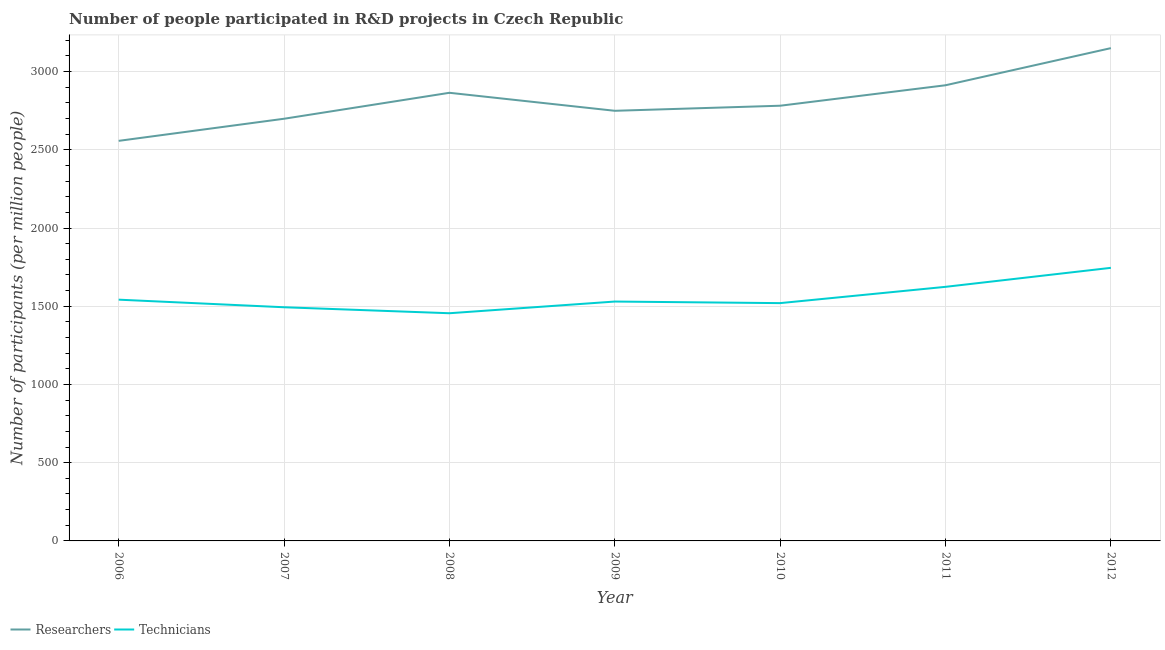Does the line corresponding to number of technicians intersect with the line corresponding to number of researchers?
Your answer should be very brief. No. Is the number of lines equal to the number of legend labels?
Keep it short and to the point. Yes. What is the number of researchers in 2010?
Keep it short and to the point. 2781.85. Across all years, what is the maximum number of researchers?
Keep it short and to the point. 3149.99. Across all years, what is the minimum number of researchers?
Offer a very short reply. 2557.31. In which year was the number of technicians maximum?
Provide a short and direct response. 2012. In which year was the number of technicians minimum?
Your answer should be very brief. 2008. What is the total number of technicians in the graph?
Your answer should be compact. 1.09e+04. What is the difference between the number of researchers in 2008 and that in 2012?
Offer a very short reply. -285.47. What is the difference between the number of researchers in 2006 and the number of technicians in 2008?
Offer a very short reply. 1101.93. What is the average number of researchers per year?
Give a very brief answer. 2816.34. In the year 2011, what is the difference between the number of technicians and number of researchers?
Provide a succinct answer. -1288.49. What is the ratio of the number of researchers in 2009 to that in 2010?
Give a very brief answer. 0.99. What is the difference between the highest and the second highest number of technicians?
Your answer should be very brief. 121.45. What is the difference between the highest and the lowest number of technicians?
Offer a terse response. 290.21. Is the sum of the number of researchers in 2009 and 2012 greater than the maximum number of technicians across all years?
Your answer should be very brief. Yes. How many lines are there?
Give a very brief answer. 2. How many years are there in the graph?
Provide a succinct answer. 7. What is the difference between two consecutive major ticks on the Y-axis?
Give a very brief answer. 500. Does the graph contain any zero values?
Provide a succinct answer. No. Does the graph contain grids?
Your response must be concise. Yes. Where does the legend appear in the graph?
Offer a terse response. Bottom left. What is the title of the graph?
Provide a short and direct response. Number of people participated in R&D projects in Czech Republic. Does "Exports" appear as one of the legend labels in the graph?
Offer a very short reply. No. What is the label or title of the Y-axis?
Your answer should be compact. Number of participants (per million people). What is the Number of participants (per million people) of Researchers in 2006?
Your answer should be compact. 2557.31. What is the Number of participants (per million people) in Technicians in 2006?
Provide a succinct answer. 1542.15. What is the Number of participants (per million people) of Researchers in 2007?
Ensure brevity in your answer.  2698.6. What is the Number of participants (per million people) in Technicians in 2007?
Keep it short and to the point. 1493.68. What is the Number of participants (per million people) of Researchers in 2008?
Ensure brevity in your answer.  2864.52. What is the Number of participants (per million people) in Technicians in 2008?
Offer a very short reply. 1455.38. What is the Number of participants (per million people) in Researchers in 2009?
Provide a short and direct response. 2749.45. What is the Number of participants (per million people) of Technicians in 2009?
Your response must be concise. 1530.09. What is the Number of participants (per million people) in Researchers in 2010?
Offer a terse response. 2781.85. What is the Number of participants (per million people) of Technicians in 2010?
Provide a succinct answer. 1520.06. What is the Number of participants (per million people) of Researchers in 2011?
Your answer should be compact. 2912.63. What is the Number of participants (per million people) of Technicians in 2011?
Your answer should be compact. 1624.14. What is the Number of participants (per million people) in Researchers in 2012?
Offer a very short reply. 3149.99. What is the Number of participants (per million people) in Technicians in 2012?
Give a very brief answer. 1745.59. Across all years, what is the maximum Number of participants (per million people) in Researchers?
Your answer should be compact. 3149.99. Across all years, what is the maximum Number of participants (per million people) of Technicians?
Make the answer very short. 1745.59. Across all years, what is the minimum Number of participants (per million people) in Researchers?
Provide a succinct answer. 2557.31. Across all years, what is the minimum Number of participants (per million people) of Technicians?
Your answer should be very brief. 1455.38. What is the total Number of participants (per million people) of Researchers in the graph?
Ensure brevity in your answer.  1.97e+04. What is the total Number of participants (per million people) in Technicians in the graph?
Your answer should be compact. 1.09e+04. What is the difference between the Number of participants (per million people) of Researchers in 2006 and that in 2007?
Keep it short and to the point. -141.29. What is the difference between the Number of participants (per million people) in Technicians in 2006 and that in 2007?
Give a very brief answer. 48.47. What is the difference between the Number of participants (per million people) in Researchers in 2006 and that in 2008?
Offer a very short reply. -307.21. What is the difference between the Number of participants (per million people) of Technicians in 2006 and that in 2008?
Provide a succinct answer. 86.78. What is the difference between the Number of participants (per million people) in Researchers in 2006 and that in 2009?
Ensure brevity in your answer.  -192.14. What is the difference between the Number of participants (per million people) in Technicians in 2006 and that in 2009?
Make the answer very short. 12.06. What is the difference between the Number of participants (per million people) of Researchers in 2006 and that in 2010?
Provide a short and direct response. -224.55. What is the difference between the Number of participants (per million people) of Technicians in 2006 and that in 2010?
Your response must be concise. 22.1. What is the difference between the Number of participants (per million people) in Researchers in 2006 and that in 2011?
Your answer should be compact. -355.32. What is the difference between the Number of participants (per million people) in Technicians in 2006 and that in 2011?
Offer a very short reply. -81.98. What is the difference between the Number of participants (per million people) of Researchers in 2006 and that in 2012?
Your response must be concise. -592.69. What is the difference between the Number of participants (per million people) of Technicians in 2006 and that in 2012?
Provide a short and direct response. -203.43. What is the difference between the Number of participants (per million people) of Researchers in 2007 and that in 2008?
Give a very brief answer. -165.92. What is the difference between the Number of participants (per million people) of Technicians in 2007 and that in 2008?
Make the answer very short. 38.3. What is the difference between the Number of participants (per million people) in Researchers in 2007 and that in 2009?
Offer a terse response. -50.85. What is the difference between the Number of participants (per million people) of Technicians in 2007 and that in 2009?
Offer a very short reply. -36.41. What is the difference between the Number of participants (per million people) in Researchers in 2007 and that in 2010?
Keep it short and to the point. -83.26. What is the difference between the Number of participants (per million people) in Technicians in 2007 and that in 2010?
Provide a succinct answer. -26.38. What is the difference between the Number of participants (per million people) of Researchers in 2007 and that in 2011?
Make the answer very short. -214.03. What is the difference between the Number of participants (per million people) of Technicians in 2007 and that in 2011?
Provide a short and direct response. -130.45. What is the difference between the Number of participants (per million people) in Researchers in 2007 and that in 2012?
Provide a short and direct response. -451.39. What is the difference between the Number of participants (per million people) of Technicians in 2007 and that in 2012?
Make the answer very short. -251.9. What is the difference between the Number of participants (per million people) of Researchers in 2008 and that in 2009?
Provide a short and direct response. 115.07. What is the difference between the Number of participants (per million people) of Technicians in 2008 and that in 2009?
Your answer should be compact. -74.72. What is the difference between the Number of participants (per million people) of Researchers in 2008 and that in 2010?
Offer a terse response. 82.66. What is the difference between the Number of participants (per million people) of Technicians in 2008 and that in 2010?
Your answer should be very brief. -64.68. What is the difference between the Number of participants (per million people) of Researchers in 2008 and that in 2011?
Give a very brief answer. -48.11. What is the difference between the Number of participants (per million people) in Technicians in 2008 and that in 2011?
Give a very brief answer. -168.76. What is the difference between the Number of participants (per million people) in Researchers in 2008 and that in 2012?
Your answer should be very brief. -285.47. What is the difference between the Number of participants (per million people) of Technicians in 2008 and that in 2012?
Provide a succinct answer. -290.21. What is the difference between the Number of participants (per million people) in Researchers in 2009 and that in 2010?
Provide a short and direct response. -32.4. What is the difference between the Number of participants (per million people) of Technicians in 2009 and that in 2010?
Ensure brevity in your answer.  10.04. What is the difference between the Number of participants (per million people) of Researchers in 2009 and that in 2011?
Provide a short and direct response. -163.18. What is the difference between the Number of participants (per million people) in Technicians in 2009 and that in 2011?
Give a very brief answer. -94.04. What is the difference between the Number of participants (per million people) in Researchers in 2009 and that in 2012?
Give a very brief answer. -400.54. What is the difference between the Number of participants (per million people) in Technicians in 2009 and that in 2012?
Make the answer very short. -215.49. What is the difference between the Number of participants (per million people) of Researchers in 2010 and that in 2011?
Offer a very short reply. -130.77. What is the difference between the Number of participants (per million people) in Technicians in 2010 and that in 2011?
Offer a terse response. -104.08. What is the difference between the Number of participants (per million people) of Researchers in 2010 and that in 2012?
Your answer should be very brief. -368.14. What is the difference between the Number of participants (per million people) of Technicians in 2010 and that in 2012?
Your response must be concise. -225.53. What is the difference between the Number of participants (per million people) in Researchers in 2011 and that in 2012?
Your response must be concise. -237.36. What is the difference between the Number of participants (per million people) of Technicians in 2011 and that in 2012?
Keep it short and to the point. -121.45. What is the difference between the Number of participants (per million people) in Researchers in 2006 and the Number of participants (per million people) in Technicians in 2007?
Provide a succinct answer. 1063.62. What is the difference between the Number of participants (per million people) in Researchers in 2006 and the Number of participants (per million people) in Technicians in 2008?
Ensure brevity in your answer.  1101.93. What is the difference between the Number of participants (per million people) of Researchers in 2006 and the Number of participants (per million people) of Technicians in 2009?
Provide a succinct answer. 1027.21. What is the difference between the Number of participants (per million people) of Researchers in 2006 and the Number of participants (per million people) of Technicians in 2010?
Offer a terse response. 1037.25. What is the difference between the Number of participants (per million people) in Researchers in 2006 and the Number of participants (per million people) in Technicians in 2011?
Give a very brief answer. 933.17. What is the difference between the Number of participants (per million people) of Researchers in 2006 and the Number of participants (per million people) of Technicians in 2012?
Offer a very short reply. 811.72. What is the difference between the Number of participants (per million people) of Researchers in 2007 and the Number of participants (per million people) of Technicians in 2008?
Give a very brief answer. 1243.22. What is the difference between the Number of participants (per million people) in Researchers in 2007 and the Number of participants (per million people) in Technicians in 2009?
Provide a succinct answer. 1168.5. What is the difference between the Number of participants (per million people) of Researchers in 2007 and the Number of participants (per million people) of Technicians in 2010?
Offer a very short reply. 1178.54. What is the difference between the Number of participants (per million people) in Researchers in 2007 and the Number of participants (per million people) in Technicians in 2011?
Your answer should be compact. 1074.46. What is the difference between the Number of participants (per million people) in Researchers in 2007 and the Number of participants (per million people) in Technicians in 2012?
Ensure brevity in your answer.  953.01. What is the difference between the Number of participants (per million people) in Researchers in 2008 and the Number of participants (per million people) in Technicians in 2009?
Your answer should be very brief. 1334.42. What is the difference between the Number of participants (per million people) of Researchers in 2008 and the Number of participants (per million people) of Technicians in 2010?
Your answer should be very brief. 1344.46. What is the difference between the Number of participants (per million people) of Researchers in 2008 and the Number of participants (per million people) of Technicians in 2011?
Provide a succinct answer. 1240.38. What is the difference between the Number of participants (per million people) in Researchers in 2008 and the Number of participants (per million people) in Technicians in 2012?
Your response must be concise. 1118.93. What is the difference between the Number of participants (per million people) of Researchers in 2009 and the Number of participants (per million people) of Technicians in 2010?
Ensure brevity in your answer.  1229.39. What is the difference between the Number of participants (per million people) of Researchers in 2009 and the Number of participants (per million people) of Technicians in 2011?
Your response must be concise. 1125.31. What is the difference between the Number of participants (per million people) in Researchers in 2009 and the Number of participants (per million people) in Technicians in 2012?
Ensure brevity in your answer.  1003.86. What is the difference between the Number of participants (per million people) of Researchers in 2010 and the Number of participants (per million people) of Technicians in 2011?
Keep it short and to the point. 1157.72. What is the difference between the Number of participants (per million people) of Researchers in 2010 and the Number of participants (per million people) of Technicians in 2012?
Ensure brevity in your answer.  1036.27. What is the difference between the Number of participants (per million people) in Researchers in 2011 and the Number of participants (per million people) in Technicians in 2012?
Provide a short and direct response. 1167.04. What is the average Number of participants (per million people) of Researchers per year?
Provide a succinct answer. 2816.34. What is the average Number of participants (per million people) of Technicians per year?
Make the answer very short. 1558.73. In the year 2006, what is the difference between the Number of participants (per million people) of Researchers and Number of participants (per million people) of Technicians?
Ensure brevity in your answer.  1015.15. In the year 2007, what is the difference between the Number of participants (per million people) of Researchers and Number of participants (per million people) of Technicians?
Make the answer very short. 1204.92. In the year 2008, what is the difference between the Number of participants (per million people) in Researchers and Number of participants (per million people) in Technicians?
Offer a very short reply. 1409.14. In the year 2009, what is the difference between the Number of participants (per million people) of Researchers and Number of participants (per million people) of Technicians?
Give a very brief answer. 1219.36. In the year 2010, what is the difference between the Number of participants (per million people) of Researchers and Number of participants (per million people) of Technicians?
Offer a very short reply. 1261.8. In the year 2011, what is the difference between the Number of participants (per million people) of Researchers and Number of participants (per million people) of Technicians?
Provide a short and direct response. 1288.49. In the year 2012, what is the difference between the Number of participants (per million people) in Researchers and Number of participants (per million people) in Technicians?
Your answer should be very brief. 1404.41. What is the ratio of the Number of participants (per million people) in Researchers in 2006 to that in 2007?
Offer a terse response. 0.95. What is the ratio of the Number of participants (per million people) in Technicians in 2006 to that in 2007?
Offer a terse response. 1.03. What is the ratio of the Number of participants (per million people) in Researchers in 2006 to that in 2008?
Make the answer very short. 0.89. What is the ratio of the Number of participants (per million people) in Technicians in 2006 to that in 2008?
Offer a very short reply. 1.06. What is the ratio of the Number of participants (per million people) of Researchers in 2006 to that in 2009?
Your answer should be compact. 0.93. What is the ratio of the Number of participants (per million people) in Technicians in 2006 to that in 2009?
Offer a terse response. 1.01. What is the ratio of the Number of participants (per million people) of Researchers in 2006 to that in 2010?
Provide a succinct answer. 0.92. What is the ratio of the Number of participants (per million people) of Technicians in 2006 to that in 2010?
Offer a terse response. 1.01. What is the ratio of the Number of participants (per million people) of Researchers in 2006 to that in 2011?
Your answer should be compact. 0.88. What is the ratio of the Number of participants (per million people) in Technicians in 2006 to that in 2011?
Give a very brief answer. 0.95. What is the ratio of the Number of participants (per million people) of Researchers in 2006 to that in 2012?
Keep it short and to the point. 0.81. What is the ratio of the Number of participants (per million people) in Technicians in 2006 to that in 2012?
Provide a succinct answer. 0.88. What is the ratio of the Number of participants (per million people) in Researchers in 2007 to that in 2008?
Your answer should be very brief. 0.94. What is the ratio of the Number of participants (per million people) in Technicians in 2007 to that in 2008?
Provide a succinct answer. 1.03. What is the ratio of the Number of participants (per million people) of Researchers in 2007 to that in 2009?
Offer a very short reply. 0.98. What is the ratio of the Number of participants (per million people) in Technicians in 2007 to that in 2009?
Provide a succinct answer. 0.98. What is the ratio of the Number of participants (per million people) of Researchers in 2007 to that in 2010?
Keep it short and to the point. 0.97. What is the ratio of the Number of participants (per million people) of Technicians in 2007 to that in 2010?
Your answer should be very brief. 0.98. What is the ratio of the Number of participants (per million people) in Researchers in 2007 to that in 2011?
Keep it short and to the point. 0.93. What is the ratio of the Number of participants (per million people) in Technicians in 2007 to that in 2011?
Keep it short and to the point. 0.92. What is the ratio of the Number of participants (per million people) of Researchers in 2007 to that in 2012?
Ensure brevity in your answer.  0.86. What is the ratio of the Number of participants (per million people) in Technicians in 2007 to that in 2012?
Your response must be concise. 0.86. What is the ratio of the Number of participants (per million people) in Researchers in 2008 to that in 2009?
Provide a short and direct response. 1.04. What is the ratio of the Number of participants (per million people) in Technicians in 2008 to that in 2009?
Your answer should be compact. 0.95. What is the ratio of the Number of participants (per million people) of Researchers in 2008 to that in 2010?
Make the answer very short. 1.03. What is the ratio of the Number of participants (per million people) of Technicians in 2008 to that in 2010?
Give a very brief answer. 0.96. What is the ratio of the Number of participants (per million people) in Researchers in 2008 to that in 2011?
Your answer should be very brief. 0.98. What is the ratio of the Number of participants (per million people) in Technicians in 2008 to that in 2011?
Ensure brevity in your answer.  0.9. What is the ratio of the Number of participants (per million people) of Researchers in 2008 to that in 2012?
Offer a very short reply. 0.91. What is the ratio of the Number of participants (per million people) in Technicians in 2008 to that in 2012?
Ensure brevity in your answer.  0.83. What is the ratio of the Number of participants (per million people) in Researchers in 2009 to that in 2010?
Provide a short and direct response. 0.99. What is the ratio of the Number of participants (per million people) in Technicians in 2009 to that in 2010?
Your response must be concise. 1.01. What is the ratio of the Number of participants (per million people) of Researchers in 2009 to that in 2011?
Provide a short and direct response. 0.94. What is the ratio of the Number of participants (per million people) of Technicians in 2009 to that in 2011?
Offer a very short reply. 0.94. What is the ratio of the Number of participants (per million people) in Researchers in 2009 to that in 2012?
Keep it short and to the point. 0.87. What is the ratio of the Number of participants (per million people) of Technicians in 2009 to that in 2012?
Keep it short and to the point. 0.88. What is the ratio of the Number of participants (per million people) in Researchers in 2010 to that in 2011?
Your answer should be very brief. 0.96. What is the ratio of the Number of participants (per million people) of Technicians in 2010 to that in 2011?
Make the answer very short. 0.94. What is the ratio of the Number of participants (per million people) of Researchers in 2010 to that in 2012?
Make the answer very short. 0.88. What is the ratio of the Number of participants (per million people) in Technicians in 2010 to that in 2012?
Your answer should be very brief. 0.87. What is the ratio of the Number of participants (per million people) in Researchers in 2011 to that in 2012?
Keep it short and to the point. 0.92. What is the ratio of the Number of participants (per million people) in Technicians in 2011 to that in 2012?
Your answer should be compact. 0.93. What is the difference between the highest and the second highest Number of participants (per million people) of Researchers?
Your response must be concise. 237.36. What is the difference between the highest and the second highest Number of participants (per million people) of Technicians?
Provide a succinct answer. 121.45. What is the difference between the highest and the lowest Number of participants (per million people) in Researchers?
Offer a very short reply. 592.69. What is the difference between the highest and the lowest Number of participants (per million people) in Technicians?
Your response must be concise. 290.21. 